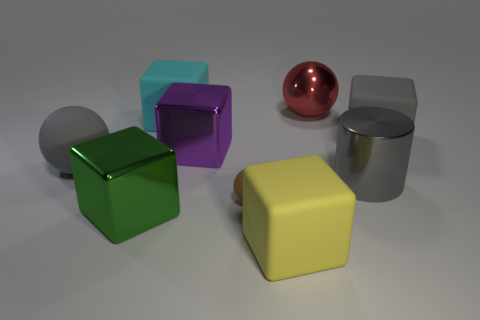Subtract all gray rubber spheres. How many spheres are left? 2 Subtract all green cubes. How many cubes are left? 4 Subtract 3 cubes. How many cubes are left? 2 Add 1 brown balls. How many objects exist? 10 Subtract all cyan cubes. Subtract all green cylinders. How many cubes are left? 4 Subtract all cylinders. How many objects are left? 8 Add 7 big brown shiny objects. How many big brown shiny objects exist? 7 Subtract 1 cyan blocks. How many objects are left? 8 Subtract all big balls. Subtract all metallic blocks. How many objects are left? 5 Add 7 large balls. How many large balls are left? 9 